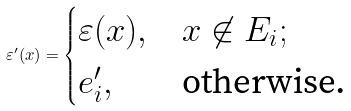Convert formula to latex. <formula><loc_0><loc_0><loc_500><loc_500>\varepsilon ^ { \prime } ( x ) = \begin{cases} \varepsilon ( x ) , & x \not \in E _ { i } ; \\ e ^ { \prime } _ { i } , & \text {otherwise.} \end{cases}</formula> 